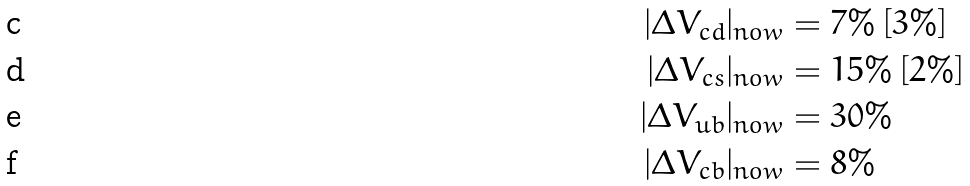<formula> <loc_0><loc_0><loc_500><loc_500>| \Delta V _ { c d } | _ { n o w } & = 7 \% \, [ 3 \% ] \\ | \Delta V _ { c s } | _ { n o w } & = 1 5 \% \, [ 2 \% ] \\ | \Delta V _ { u b } | _ { n o w } & = 3 0 \% \\ | \Delta V _ { c b } | _ { n o w } & = 8 \%</formula> 